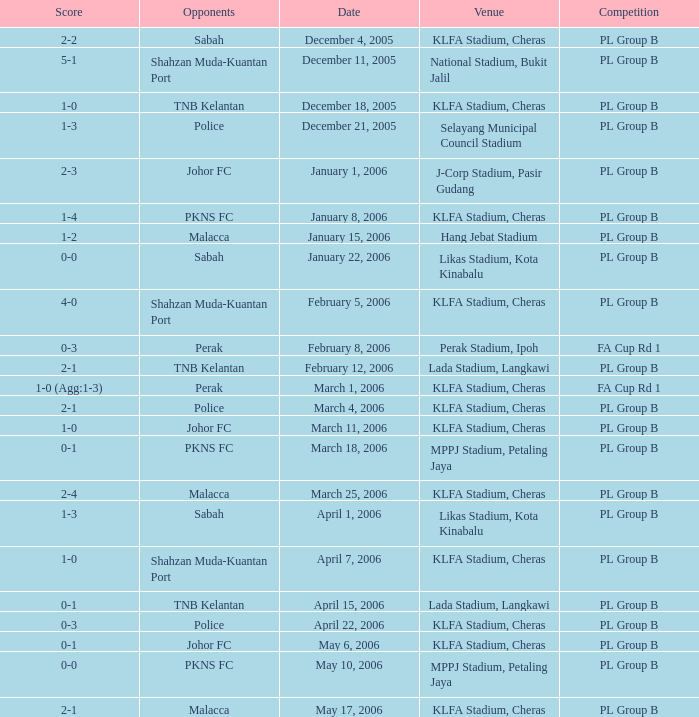Which Competition has a Score of 0-1, and Opponents of pkns fc? PL Group B. 